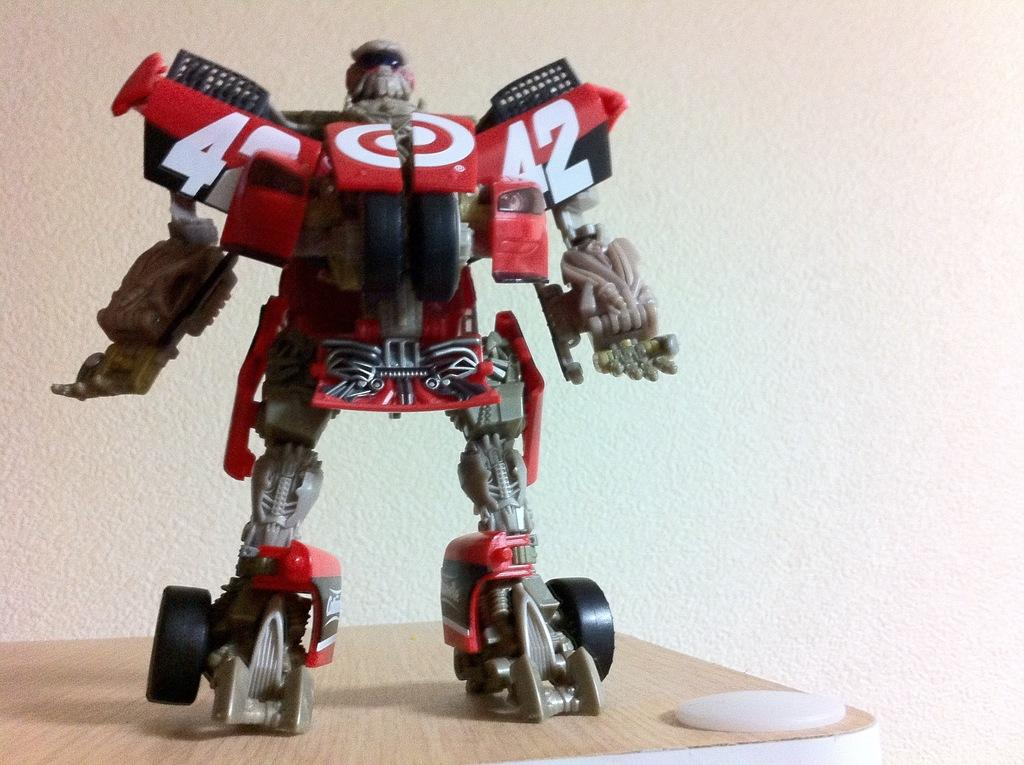What object can be seen in the image? There is a toy in the image. What color is the toy? The toy is red in color. Where is the toy placed? The toy is placed on a table. What is the color of the table? The table is cream in color. What can be seen in the background of the image? There is a white wall in the background of the image. What type of farm animals can be seen on the chalkboard in the image? There is no chalkboard or farm animals present in the image. 